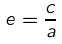Convert formula to latex. <formula><loc_0><loc_0><loc_500><loc_500>e = \frac { c } { a }</formula> 